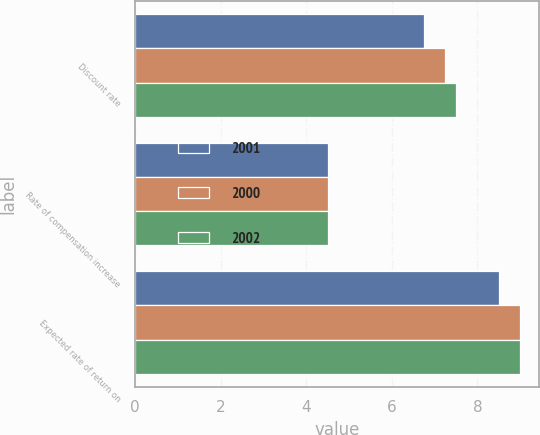Convert chart to OTSL. <chart><loc_0><loc_0><loc_500><loc_500><stacked_bar_chart><ecel><fcel>Discount rate<fcel>Rate of compensation increase<fcel>Expected rate of return on<nl><fcel>2001<fcel>6.75<fcel>4.5<fcel>8.5<nl><fcel>2000<fcel>7.25<fcel>4.5<fcel>9<nl><fcel>2002<fcel>7.5<fcel>4.5<fcel>9<nl></chart> 